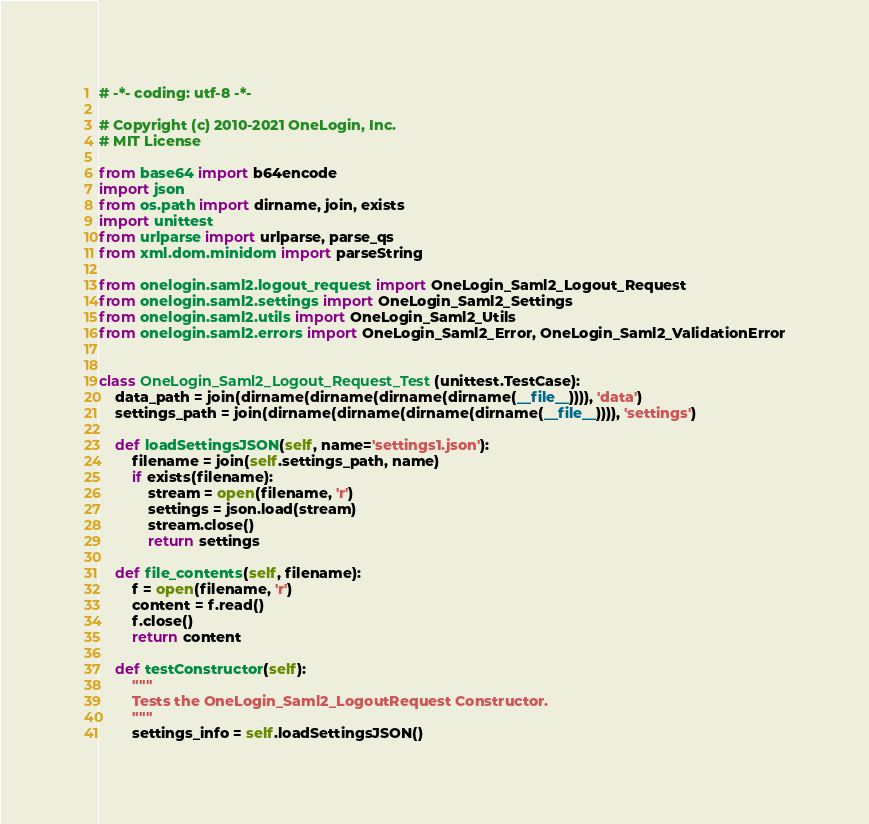Convert code to text. <code><loc_0><loc_0><loc_500><loc_500><_Python_># -*- coding: utf-8 -*-

# Copyright (c) 2010-2021 OneLogin, Inc.
# MIT License

from base64 import b64encode
import json
from os.path import dirname, join, exists
import unittest
from urlparse import urlparse, parse_qs
from xml.dom.minidom import parseString

from onelogin.saml2.logout_request import OneLogin_Saml2_Logout_Request
from onelogin.saml2.settings import OneLogin_Saml2_Settings
from onelogin.saml2.utils import OneLogin_Saml2_Utils
from onelogin.saml2.errors import OneLogin_Saml2_Error, OneLogin_Saml2_ValidationError


class OneLogin_Saml2_Logout_Request_Test(unittest.TestCase):
    data_path = join(dirname(dirname(dirname(dirname(__file__)))), 'data')
    settings_path = join(dirname(dirname(dirname(dirname(__file__)))), 'settings')

    def loadSettingsJSON(self, name='settings1.json'):
        filename = join(self.settings_path, name)
        if exists(filename):
            stream = open(filename, 'r')
            settings = json.load(stream)
            stream.close()
            return settings

    def file_contents(self, filename):
        f = open(filename, 'r')
        content = f.read()
        f.close()
        return content

    def testConstructor(self):
        """
        Tests the OneLogin_Saml2_LogoutRequest Constructor.
        """
        settings_info = self.loadSettingsJSON()</code> 